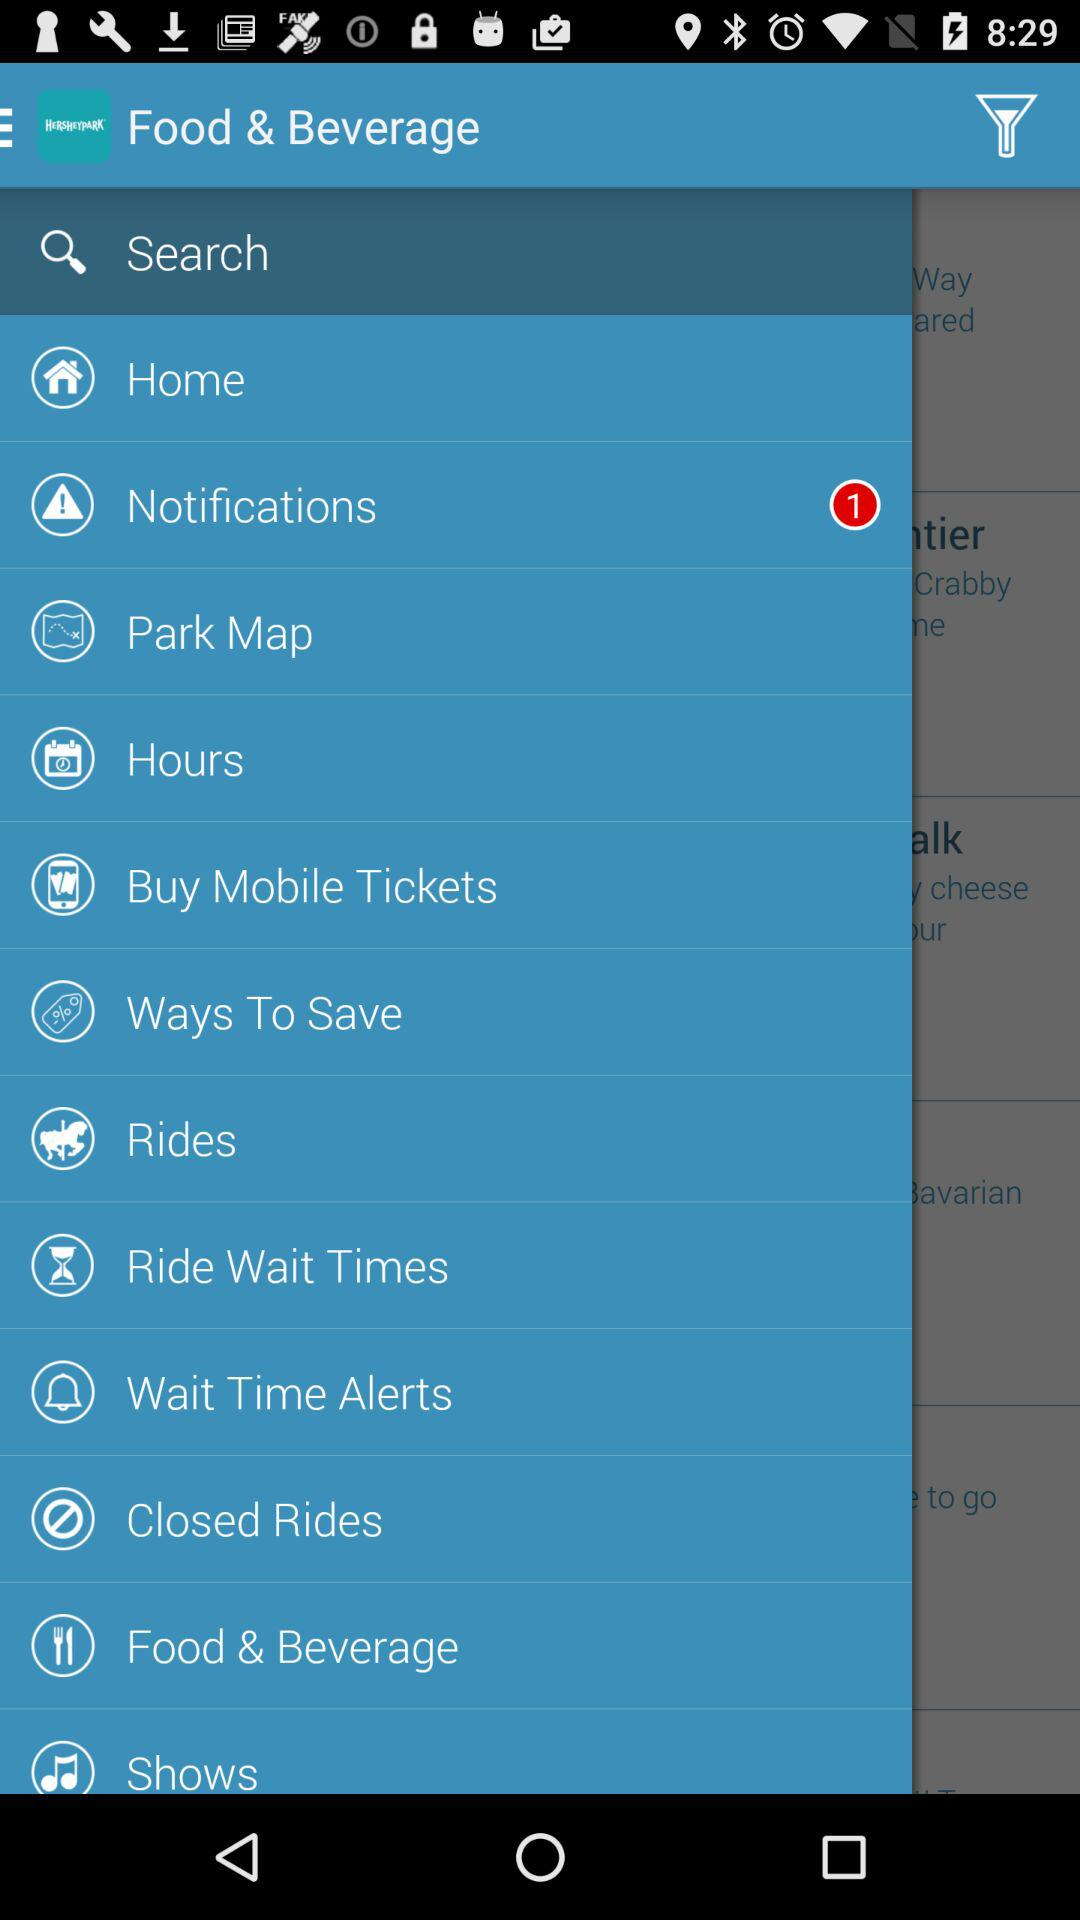How many notifications are pending? There is 1 pending notification. 